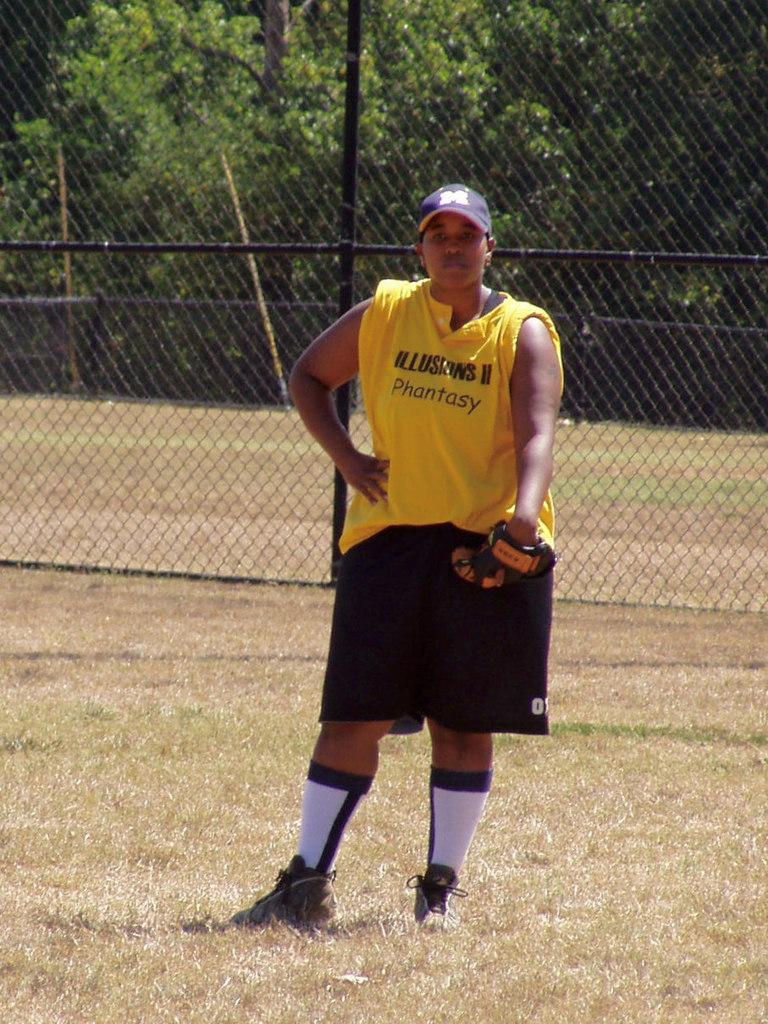<image>
Present a compact description of the photo's key features. A man on a sports field wearing a yellow vest which reads Phantasy. 